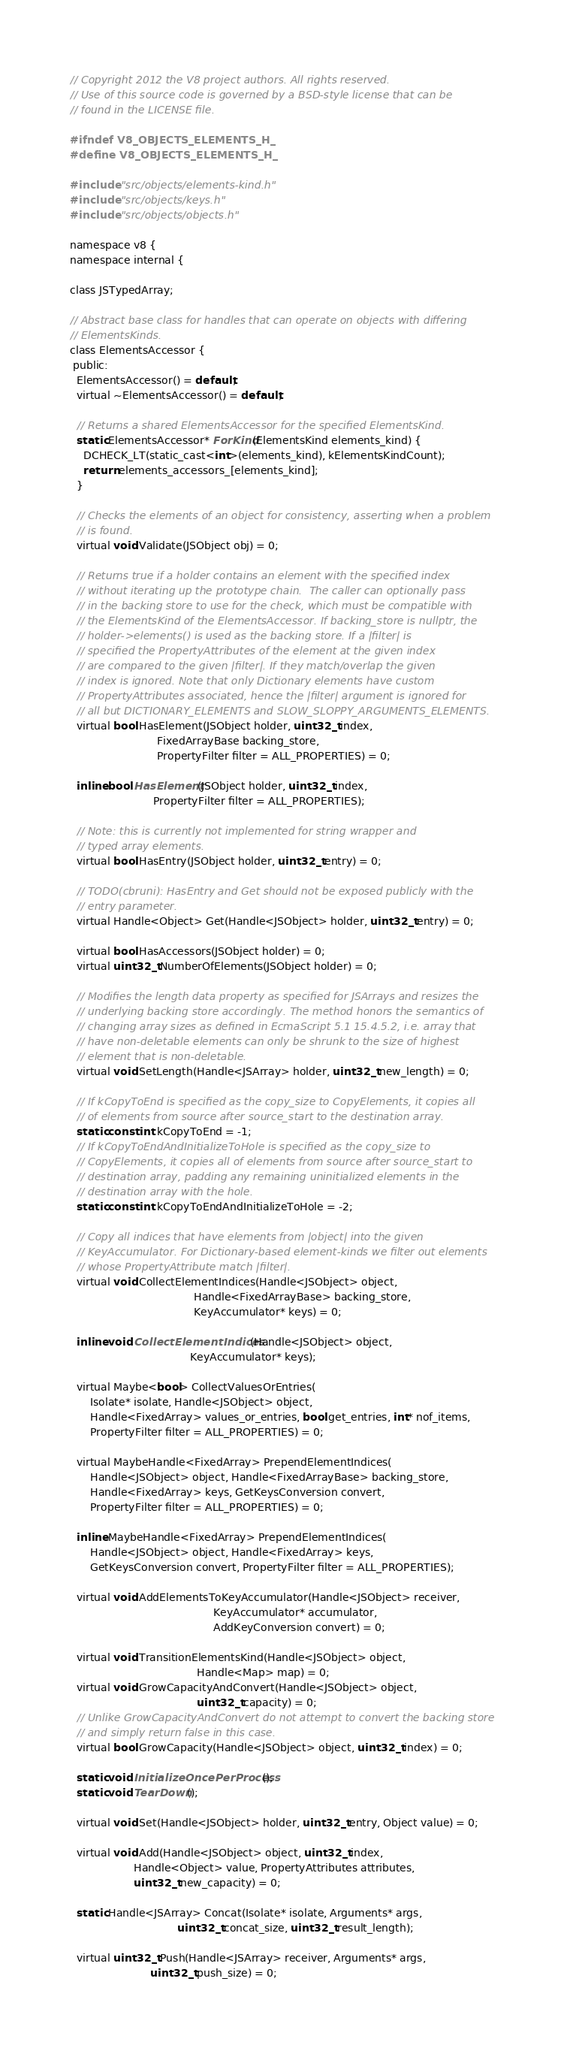<code> <loc_0><loc_0><loc_500><loc_500><_C_>// Copyright 2012 the V8 project authors. All rights reserved.
// Use of this source code is governed by a BSD-style license that can be
// found in the LICENSE file.

#ifndef V8_OBJECTS_ELEMENTS_H_
#define V8_OBJECTS_ELEMENTS_H_

#include "src/objects/elements-kind.h"
#include "src/objects/keys.h"
#include "src/objects/objects.h"

namespace v8 {
namespace internal {

class JSTypedArray;

// Abstract base class for handles that can operate on objects with differing
// ElementsKinds.
class ElementsAccessor {
 public:
  ElementsAccessor() = default;
  virtual ~ElementsAccessor() = default;

  // Returns a shared ElementsAccessor for the specified ElementsKind.
  static ElementsAccessor* ForKind(ElementsKind elements_kind) {
    DCHECK_LT(static_cast<int>(elements_kind), kElementsKindCount);
    return elements_accessors_[elements_kind];
  }

  // Checks the elements of an object for consistency, asserting when a problem
  // is found.
  virtual void Validate(JSObject obj) = 0;

  // Returns true if a holder contains an element with the specified index
  // without iterating up the prototype chain.  The caller can optionally pass
  // in the backing store to use for the check, which must be compatible with
  // the ElementsKind of the ElementsAccessor. If backing_store is nullptr, the
  // holder->elements() is used as the backing store. If a |filter| is
  // specified the PropertyAttributes of the element at the given index
  // are compared to the given |filter|. If they match/overlap the given
  // index is ignored. Note that only Dictionary elements have custom
  // PropertyAttributes associated, hence the |filter| argument is ignored for
  // all but DICTIONARY_ELEMENTS and SLOW_SLOPPY_ARGUMENTS_ELEMENTS.
  virtual bool HasElement(JSObject holder, uint32_t index,
                          FixedArrayBase backing_store,
                          PropertyFilter filter = ALL_PROPERTIES) = 0;

  inline bool HasElement(JSObject holder, uint32_t index,
                         PropertyFilter filter = ALL_PROPERTIES);

  // Note: this is currently not implemented for string wrapper and
  // typed array elements.
  virtual bool HasEntry(JSObject holder, uint32_t entry) = 0;

  // TODO(cbruni): HasEntry and Get should not be exposed publicly with the
  // entry parameter.
  virtual Handle<Object> Get(Handle<JSObject> holder, uint32_t entry) = 0;

  virtual bool HasAccessors(JSObject holder) = 0;
  virtual uint32_t NumberOfElements(JSObject holder) = 0;

  // Modifies the length data property as specified for JSArrays and resizes the
  // underlying backing store accordingly. The method honors the semantics of
  // changing array sizes as defined in EcmaScript 5.1 15.4.5.2, i.e. array that
  // have non-deletable elements can only be shrunk to the size of highest
  // element that is non-deletable.
  virtual void SetLength(Handle<JSArray> holder, uint32_t new_length) = 0;

  // If kCopyToEnd is specified as the copy_size to CopyElements, it copies all
  // of elements from source after source_start to the destination array.
  static const int kCopyToEnd = -1;
  // If kCopyToEndAndInitializeToHole is specified as the copy_size to
  // CopyElements, it copies all of elements from source after source_start to
  // destination array, padding any remaining uninitialized elements in the
  // destination array with the hole.
  static const int kCopyToEndAndInitializeToHole = -2;

  // Copy all indices that have elements from |object| into the given
  // KeyAccumulator. For Dictionary-based element-kinds we filter out elements
  // whose PropertyAttribute match |filter|.
  virtual void CollectElementIndices(Handle<JSObject> object,
                                     Handle<FixedArrayBase> backing_store,
                                     KeyAccumulator* keys) = 0;

  inline void CollectElementIndices(Handle<JSObject> object,
                                    KeyAccumulator* keys);

  virtual Maybe<bool> CollectValuesOrEntries(
      Isolate* isolate, Handle<JSObject> object,
      Handle<FixedArray> values_or_entries, bool get_entries, int* nof_items,
      PropertyFilter filter = ALL_PROPERTIES) = 0;

  virtual MaybeHandle<FixedArray> PrependElementIndices(
      Handle<JSObject> object, Handle<FixedArrayBase> backing_store,
      Handle<FixedArray> keys, GetKeysConversion convert,
      PropertyFilter filter = ALL_PROPERTIES) = 0;

  inline MaybeHandle<FixedArray> PrependElementIndices(
      Handle<JSObject> object, Handle<FixedArray> keys,
      GetKeysConversion convert, PropertyFilter filter = ALL_PROPERTIES);

  virtual void AddElementsToKeyAccumulator(Handle<JSObject> receiver,
                                           KeyAccumulator* accumulator,
                                           AddKeyConversion convert) = 0;

  virtual void TransitionElementsKind(Handle<JSObject> object,
                                      Handle<Map> map) = 0;
  virtual void GrowCapacityAndConvert(Handle<JSObject> object,
                                      uint32_t capacity) = 0;
  // Unlike GrowCapacityAndConvert do not attempt to convert the backing store
  // and simply return false in this case.
  virtual bool GrowCapacity(Handle<JSObject> object, uint32_t index) = 0;

  static void InitializeOncePerProcess();
  static void TearDown();

  virtual void Set(Handle<JSObject> holder, uint32_t entry, Object value) = 0;

  virtual void Add(Handle<JSObject> object, uint32_t index,
                   Handle<Object> value, PropertyAttributes attributes,
                   uint32_t new_capacity) = 0;

  static Handle<JSArray> Concat(Isolate* isolate, Arguments* args,
                                uint32_t concat_size, uint32_t result_length);

  virtual uint32_t Push(Handle<JSArray> receiver, Arguments* args,
                        uint32_t push_size) = 0;
</code> 